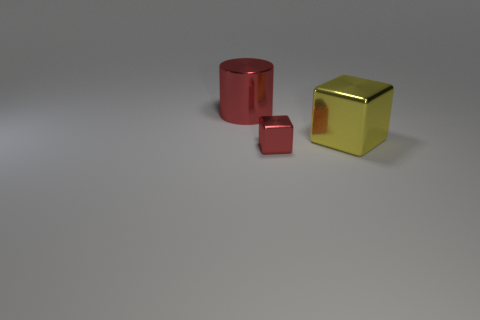Add 3 big red metallic cylinders. How many objects exist? 6 Subtract all blocks. How many objects are left? 1 Add 2 cyan matte spheres. How many cyan matte spheres exist? 2 Subtract 0 blue cubes. How many objects are left? 3 Subtract all big yellow cubes. Subtract all big red shiny cylinders. How many objects are left? 1 Add 2 large yellow metal blocks. How many large yellow metal blocks are left? 3 